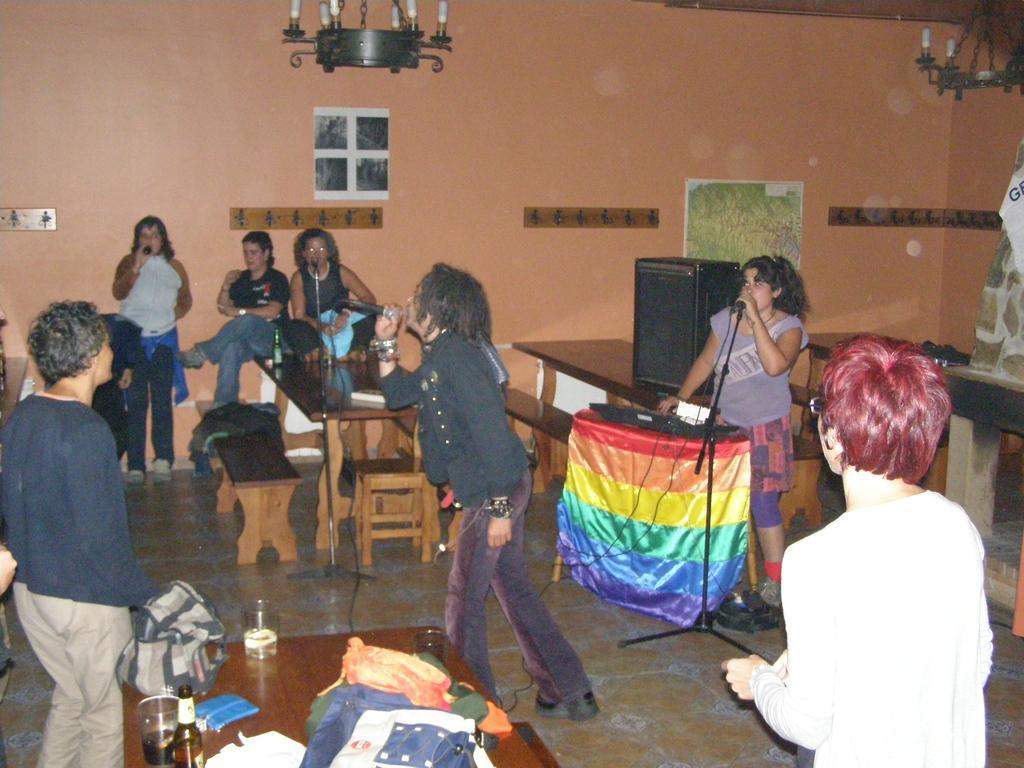How would you summarize this image in a sentence or two? In this picture there is a man who is wearing a shirt, jeans and shoes. He is also holding a mic. Behind him we can see a girl who is singing on the mic and playing piano. On the table we can see speakers and other objects. On the bottom table we can see the wine glasses, wine bottle, bag, clothes, t-shirts, book and other objects. On the right there is a woman who is wearing spectacle and white dress. On the top we can see a chandelier. Here we can see posts on the wall. On the left we can see group of person standing near to the bench. 